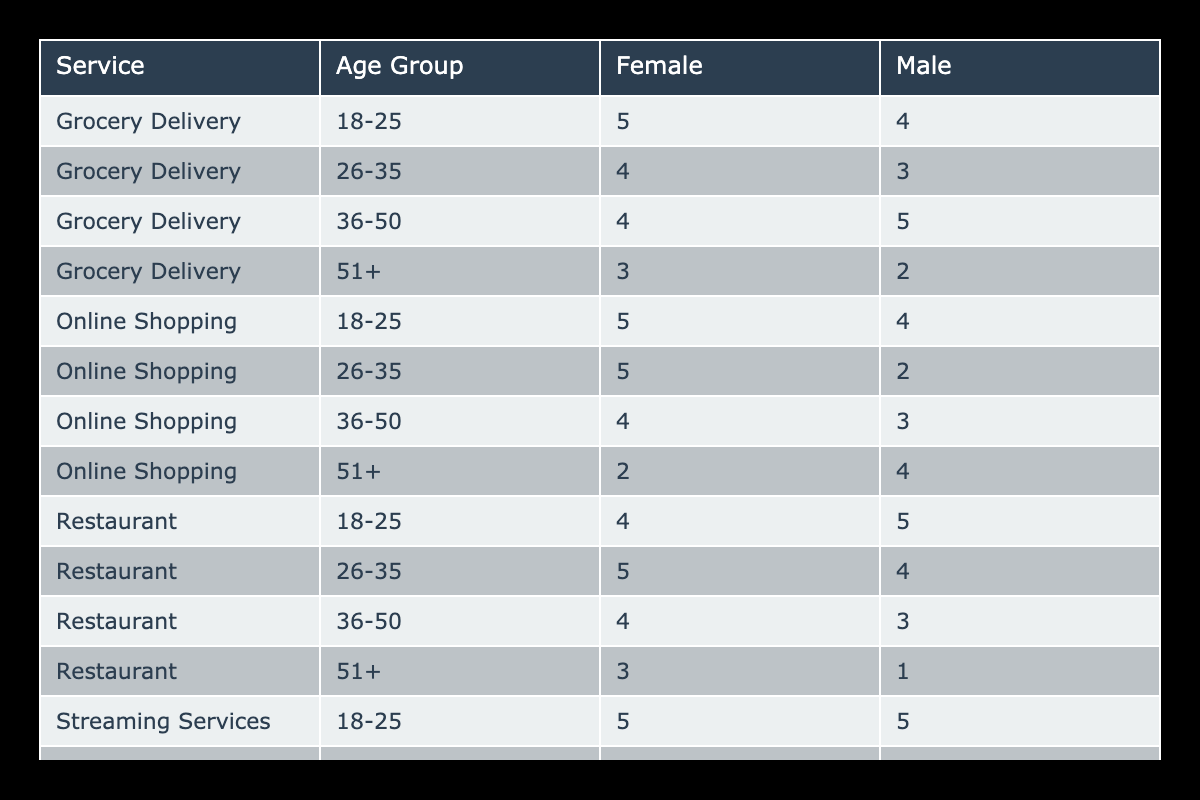What is the highest satisfaction rating for Grocery Delivery among females? The Grocery Delivery service offers ratings for females in different age groups. By examining these ratings, the highest value recorded is 5 from the age group 18-25.
Answer: 5 What age group shows the lowest satisfaction rating for the Restaurant service? Looking at the Restaurant service ratings across age groups, the 51+ age group has the lowest rating, which is 1.
Answer: 1 Which gender has a higher average satisfaction rating for Streaming Services? For the Streaming Services, the average satisfaction ratings for males is calculated as (5 + 3 + 4 + 2) / 4 = 3.5, and for females it is (5 + 4 + 5 + 3) / 4 = 4.25. Comparing these averages, females have a higher rating.
Answer: Females Is there any age group for Online Shopping where males have a satisfaction rating of 5? Checking through the Online Shopping data, I see that the male rating for the 18-25 age group is 4, in the 26-35 it’s 2, and for the 51+ it’s 4 as well, evidently showing no instance of a rating of 5 for males.
Answer: No What is the average satisfaction rating for females across all services in the 36-50 age group? For females in the 36-50 age group, the satisfaction ratings for different services are 4 (Grocery Delivery) + 4 (Restaurant) + 4 (Online Shopping) + 5 (Streaming Services), which totals 17. Dividing by 4 gives an average rating of 4.25.
Answer: 4.25 